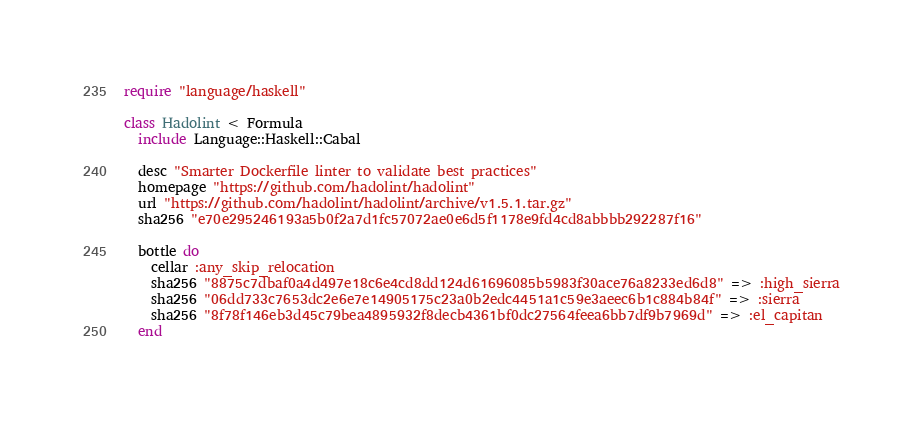Convert code to text. <code><loc_0><loc_0><loc_500><loc_500><_Ruby_>require "language/haskell"

class Hadolint < Formula
  include Language::Haskell::Cabal

  desc "Smarter Dockerfile linter to validate best practices"
  homepage "https://github.com/hadolint/hadolint"
  url "https://github.com/hadolint/hadolint/archive/v1.5.1.tar.gz"
  sha256 "e70e295246193a5b0f2a7d1fc57072ae0e6d5f1178e9fd4cd8abbbb292287f16"

  bottle do
    cellar :any_skip_relocation
    sha256 "8875c7dbaf0a4d497e18c6e4cd8dd124d61696085b5983f30ace76a8233ed6d8" => :high_sierra
    sha256 "06dd733c7653dc2e6e7e14905175c23a0b2edc4451a1c59e3aeec6b1c884b84f" => :sierra
    sha256 "8f78f146eb3d45c79bea4895932f8decb4361bf0dc27564feea6bb7df9b7969d" => :el_capitan
  end
</code> 